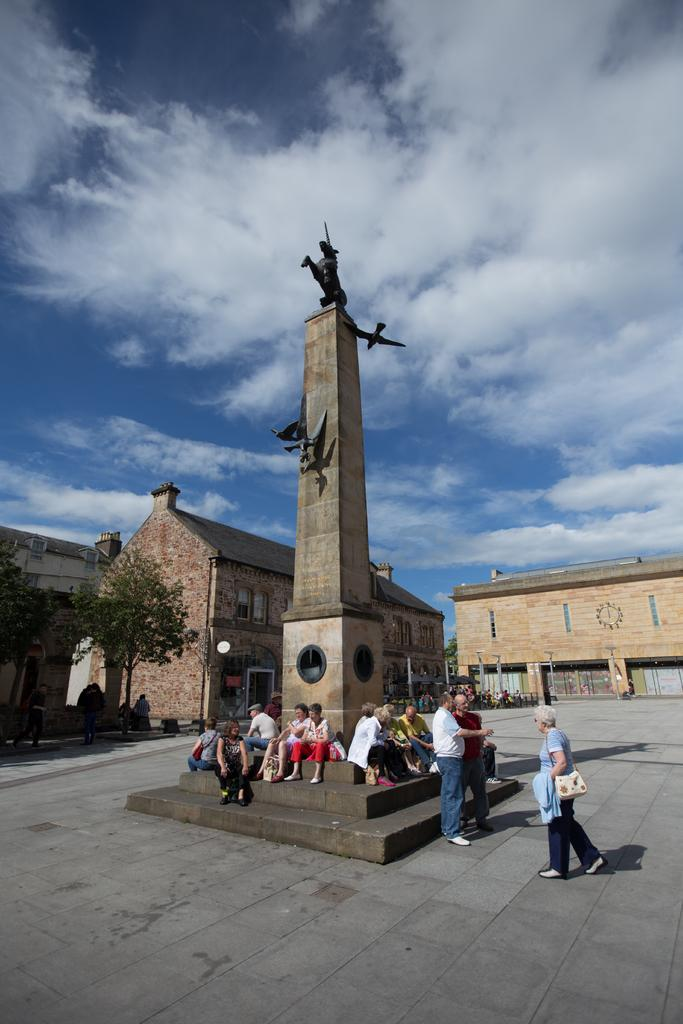How many people are in the image? There are people in the image, but the exact number is not specified. What are the people in the image doing? Some people are sitting, while others are standing. What can be seen in the image besides the people? There is a statue, buildings, trees, and the sky visible in the background of the image. What type of smoke can be seen coming from the statue in the image? There is no smoke present in the image, and the statue is not emitting any smoke. 